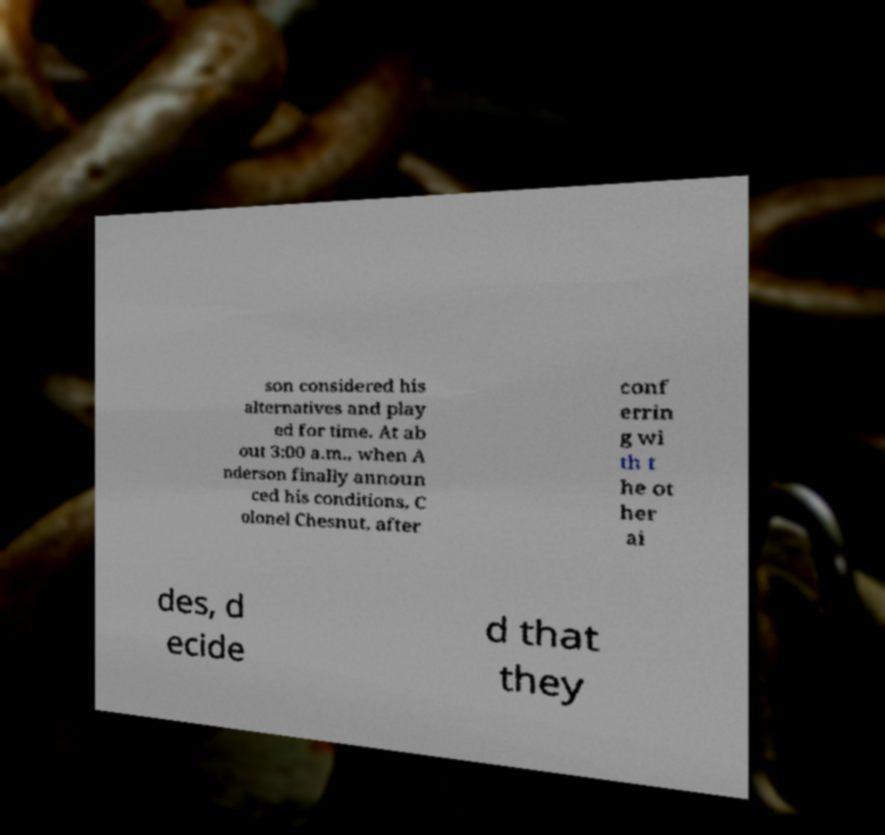Could you assist in decoding the text presented in this image and type it out clearly? son considered his alternatives and play ed for time. At ab out 3:00 a.m., when A nderson finally announ ced his conditions, C olonel Chesnut, after conf errin g wi th t he ot her ai des, d ecide d that they 